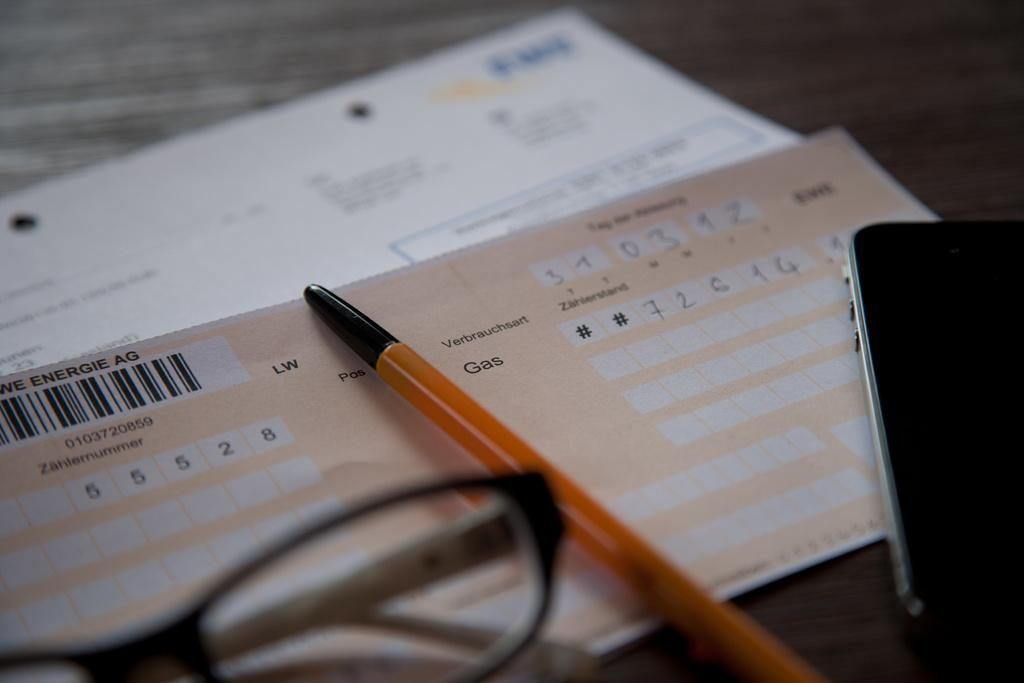<image>
Render a clear and concise summary of the photo. A German note about the gas bill lies on the counter under a pen. 